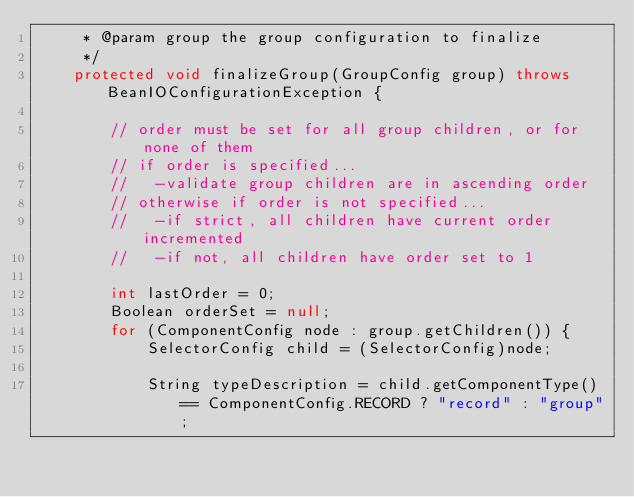Convert code to text. <code><loc_0><loc_0><loc_500><loc_500><_Java_>     * @param group the group configuration to finalize
     */
    protected void finalizeGroup(GroupConfig group) throws BeanIOConfigurationException {
        
        // order must be set for all group children, or for none of them
        // if order is specified...
        //   -validate group children are in ascending order
        // otherwise if order is not specified...
        //   -if strict, all children have current order incremented
        //   -if not, all children have order set to 1
        
        int lastOrder = 0;
        Boolean orderSet = null;
        for (ComponentConfig node : group.getChildren()) {
            SelectorConfig child = (SelectorConfig)node;
            
            String typeDescription = child.getComponentType() == ComponentConfig.RECORD ? "record" : "group";
</code> 